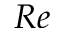<formula> <loc_0><loc_0><loc_500><loc_500>R e</formula> 